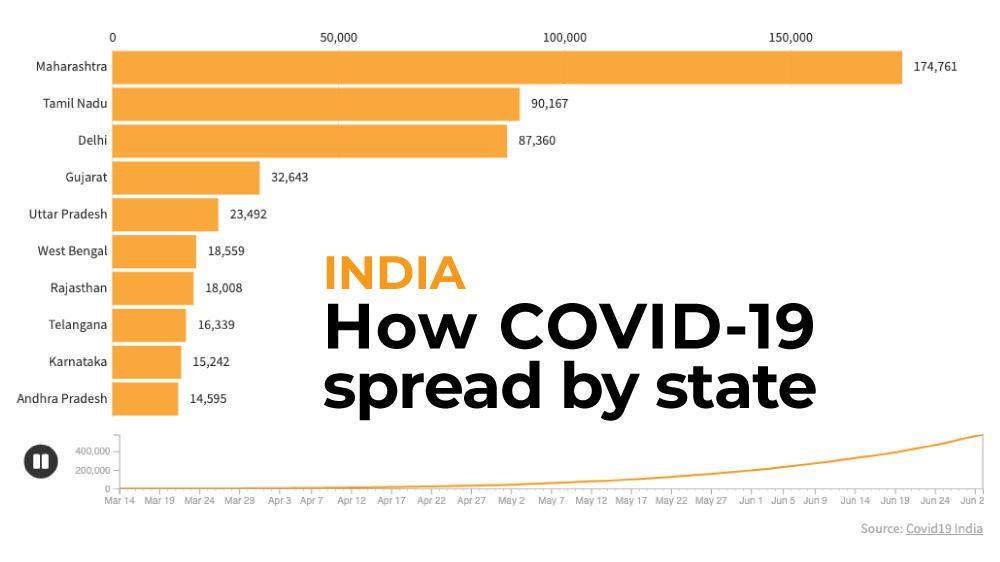Highlight a few significant elements in this photo. As of March 27, the number of Covid-19 cases in Uttar Pradesh was 23,492. As of April 1, the number of Covid-19 cases in Gujarat was 32,643. On March 23, the number of Covid-19 cases in Telangana was 16,339. As of May 4, the number of Covid-19 cases in Tamil Nadu was 90,167. As of March 22, there were 15,242 confirmed cases of Covid-19 in Karnataka. 